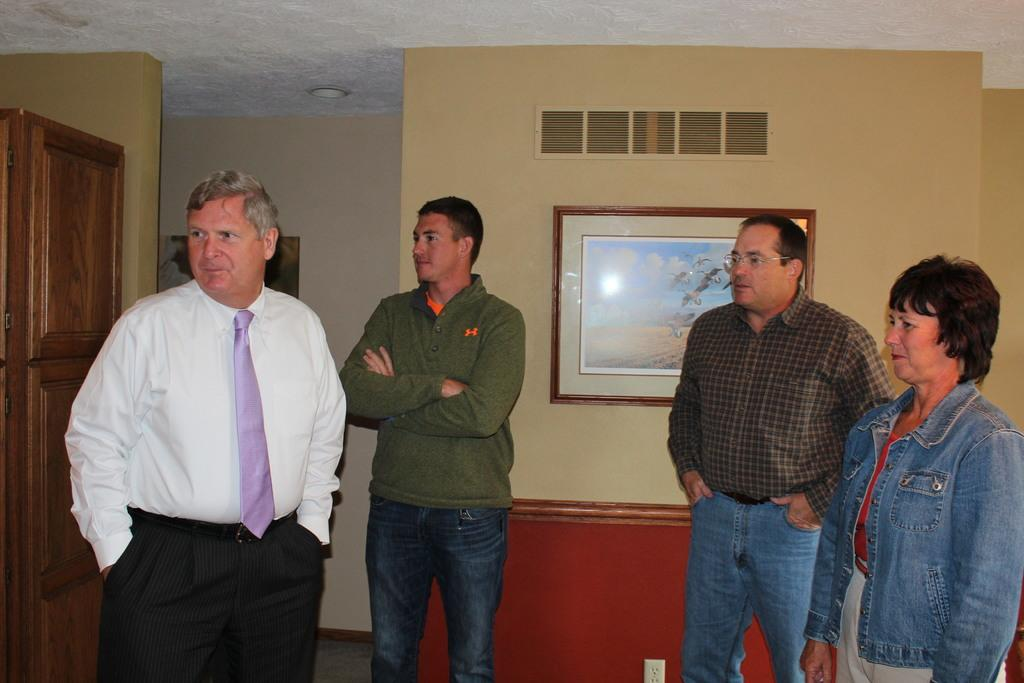What can be seen in the foreground of the image? There are people standing in the foreground of the image. What is located in the background of the image? There is a frame, a lamp, and a door in the background of the image. Can you describe the frame in the background? Unfortunately, the facts provided do not give any details about the frame. What might be the purpose of the door in the background? The door in the background could be used for entering or exiting a room or space. What type of machine can be seen operating in the background of the image? There is no machine present in the image. What industry does the cup in the foreground belong to? There is no cup present in the image. 